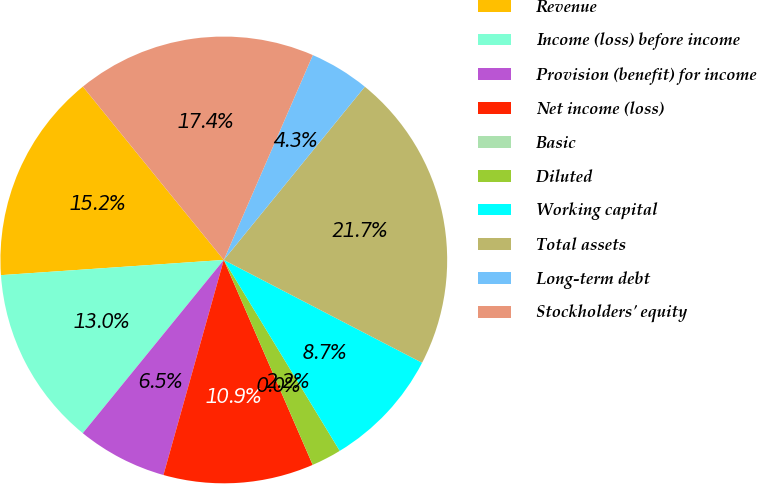<chart> <loc_0><loc_0><loc_500><loc_500><pie_chart><fcel>Revenue<fcel>Income (loss) before income<fcel>Provision (benefit) for income<fcel>Net income (loss)<fcel>Basic<fcel>Diluted<fcel>Working capital<fcel>Total assets<fcel>Long-term debt<fcel>Stockholders' equity<nl><fcel>15.22%<fcel>13.04%<fcel>6.52%<fcel>10.87%<fcel>0.0%<fcel>2.17%<fcel>8.7%<fcel>21.74%<fcel>4.35%<fcel>17.39%<nl></chart> 